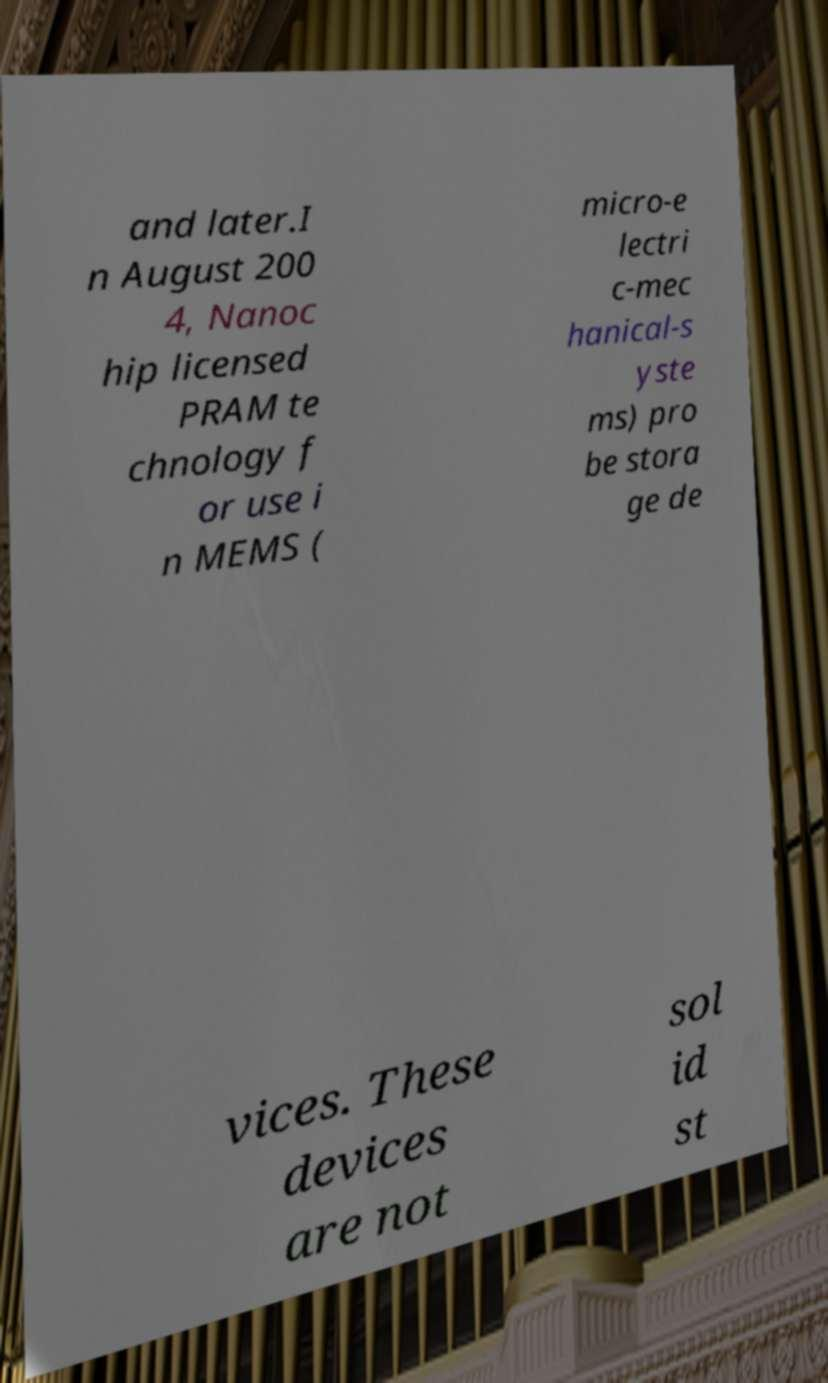I need the written content from this picture converted into text. Can you do that? and later.I n August 200 4, Nanoc hip licensed PRAM te chnology f or use i n MEMS ( micro-e lectri c-mec hanical-s yste ms) pro be stora ge de vices. These devices are not sol id st 